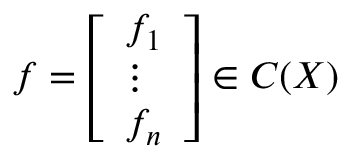Convert formula to latex. <formula><loc_0><loc_0><loc_500><loc_500>f = { \left [ \begin{array} { l } { f _ { 1 } } \\ { \vdots } \\ { f _ { n } } \end{array} \right ] } \in C ( X )</formula> 